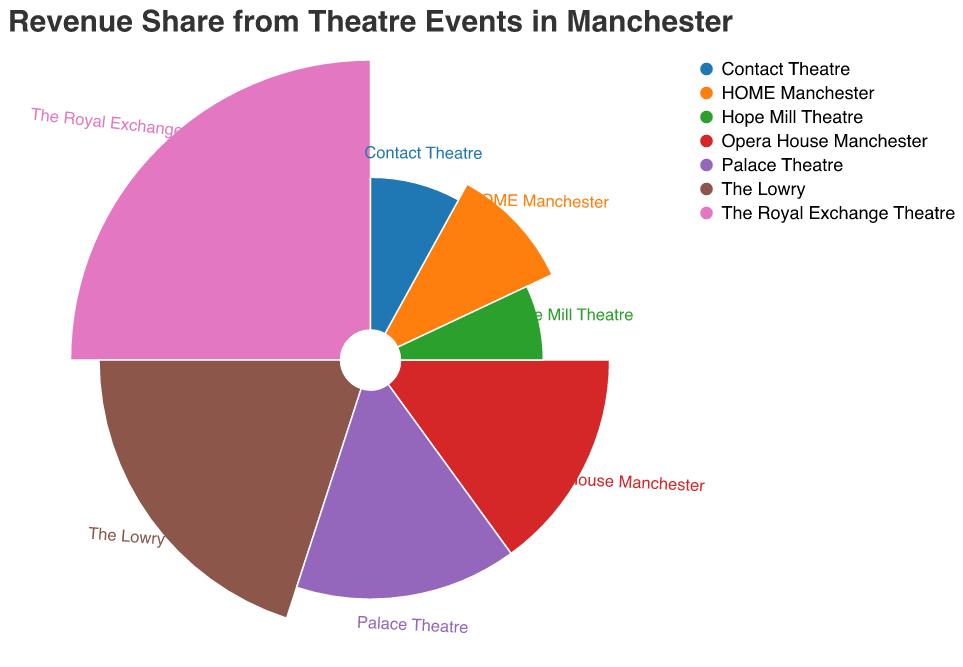What is the title of the figure? The title is mentioned at the top of the figure, reading "Revenue Share from Theatre Events in Manchester".
Answer: Revenue Share from Theatre Events in Manchester Which theatre has the highest revenue share? The Royal Exchange Theatre has the highest revenue percentage, shown as the largest arc on the chart.
Answer: The Royal Exchange Theatre What percentage of revenue does The Lowry contribute? The percentage information is displayed next to The Lowry's arc on the chart, indicating it contributes 20%.
Answer: 20% Which theatres contribute the same revenue percentage? The chart shows both the Opera House Manchester and Palace Theatre segments as having identical spans, each with 15%.
Answer: Opera House Manchester and Palace Theatre What is the smallest revenue share percentage displayed? The smallest segment on the polar chart belongs to Hope Mill Theatre, which contributes 7%.
Answer: 7% How much greater is the revenue share of The Royal Exchange Theatre compared to HOME Manchester? The Royal Exchange Theatre has a revenue share of 25%, while HOME Manchester has 10%. The difference is 25 - 10.
Answer: 15% What is the combined revenue share of Contact Theatre and Hope Mill Theatre? Contact Theatre has 8% and Hope Mill Theatre has 7%. Adding these together gives 8 + 7 = 15.
Answer: 15 What is the average revenue share of all the theatres listed? Add the percentages and then divide by the number of theatres. (25 + 20 + 15 + 15 + 10 + 8 + 7) / 7 = 100 / 7 ≈ 14.29.
Answer: ≈ 14.29 Which theatres have a revenue share equal to or greater than 15%? The Royal Exchange Theatre, The Lowry, Opera House Manchester, and Palace Theatre all have percentages equal to or greater than 15%.
Answer: The Royal Exchange Theatre, The Lowry, Opera House Manchester, and Palace Theatre 